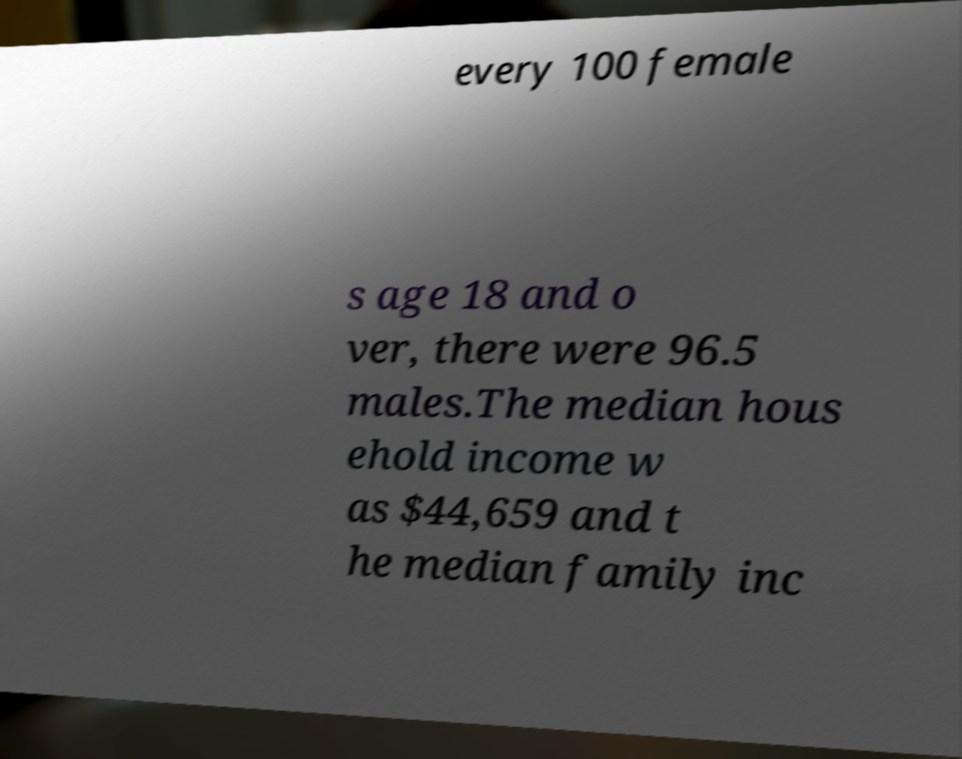For documentation purposes, I need the text within this image transcribed. Could you provide that? every 100 female s age 18 and o ver, there were 96.5 males.The median hous ehold income w as $44,659 and t he median family inc 